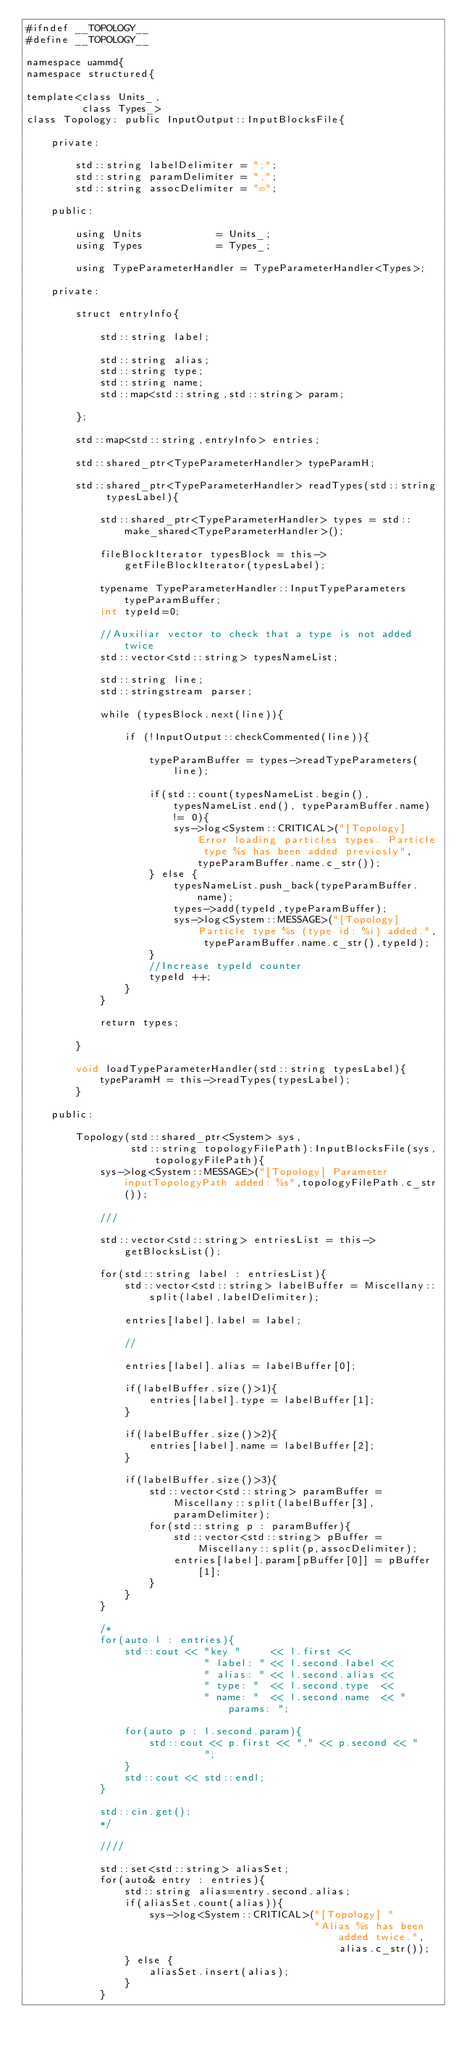Convert code to text. <code><loc_0><loc_0><loc_500><loc_500><_Cuda_>#ifndef __TOPOLOGY__
#define __TOPOLOGY__

namespace uammd{
namespace structured{

template<class Units_,
         class Types_>
class Topology: public InputOutput::InputBlocksFile{
    
    private:
        
        std::string labelDelimiter = ";";
        std::string paramDelimiter = ",";
        std::string assocDelimiter = "=";

    public:

        using Units            = Units_;
        using Types            = Types_;

        using TypeParameterHandler = TypeParameterHandler<Types>;

    private:

        struct entryInfo{
            
            std::string label;

            std::string alias;
            std::string type;
            std::string name;
            std::map<std::string,std::string> param;

        };
        
        std::map<std::string,entryInfo> entries;

        std::shared_ptr<TypeParameterHandler> typeParamH;
        
        std::shared_ptr<TypeParameterHandler> readTypes(std::string typesLabel){
            
            std::shared_ptr<TypeParameterHandler> types = std::make_shared<TypeParameterHandler>();
            
            fileBlockIterator typesBlock = this->getFileBlockIterator(typesLabel);

            typename TypeParameterHandler::InputTypeParameters typeParamBuffer;
            int typeId=0;

            //Auxiliar vector to check that a type is not added twice
            std::vector<std::string> typesNameList;
            
            std::string line;
            std::stringstream parser;

            while (typesBlock.next(line)){
                
                if (!InputOutput::checkCommented(line)){

                    typeParamBuffer = types->readTypeParameters(line);

                    if(std::count(typesNameList.begin(), typesNameList.end(), typeParamBuffer.name) != 0){
                        sys->log<System::CRITICAL>("[Topology] Error loading particles types. Particle type %s has been added previosly", typeParamBuffer.name.c_str());
                    } else {
                        typesNameList.push_back(typeParamBuffer.name);
                        types->add(typeId,typeParamBuffer);
                        sys->log<System::MESSAGE>("[Topology] Particle type %s (type id: %i) added.", typeParamBuffer.name.c_str(),typeId);
                    }
                    //Increase typeId counter
                    typeId ++;
                }
            }

            return types;

        }
        
        void loadTypeParameterHandler(std::string typesLabel){
            typeParamH = this->readTypes(typesLabel);
        }

    public:
        
        Topology(std::shared_ptr<System> sys,
                 std::string topologyFilePath):InputBlocksFile(sys,topologyFilePath){
            sys->log<System::MESSAGE>("[Topology] Parameter inputTopologyPath added: %s",topologyFilePath.c_str());

            ///

            std::vector<std::string> entriesList = this->getBlocksList();

            for(std::string label : entriesList){
                std::vector<std::string> labelBuffer = Miscellany::split(label,labelDelimiter);

                entries[label].label = label;

                //
                
                entries[label].alias = labelBuffer[0];
                
                if(labelBuffer.size()>1){
                    entries[label].type = labelBuffer[1];
                }

                if(labelBuffer.size()>2){
                    entries[label].name = labelBuffer[2];
                }

                if(labelBuffer.size()>3){
                    std::vector<std::string> paramBuffer = Miscellany::split(labelBuffer[3],paramDelimiter);
                    for(std::string p : paramBuffer){
                        std::vector<std::string> pBuffer = Miscellany::split(p,assocDelimiter);
                        entries[label].param[pBuffer[0]] = pBuffer[1];
                    }
                }
            }

            /*
            for(auto l : entries){
                std::cout << "key "     << l.first << 
                             " label: " << l.second.label << 
                             " alias: " << l.second.alias << 
                             " type: "  << l.second.type  << 
                             " name: "  << l.second.name  << " params: ";

                for(auto p : l.second.param){
                    std::cout << p.first << "," << p.second << "      ";
                }
                std::cout << std::endl;
            }
            
            std::cin.get();
            */

            ////
            
            std::set<std::string> aliasSet;
            for(auto& entry : entries){
                std::string alias=entry.second.alias;
                if(aliasSet.count(alias)){
                    sys->log<System::CRITICAL>("[Topology] "
                                               "Alias %s has been added twice.",alias.c_str());
                } else {
                    aliasSet.insert(alias);
                }
            }
</code> 